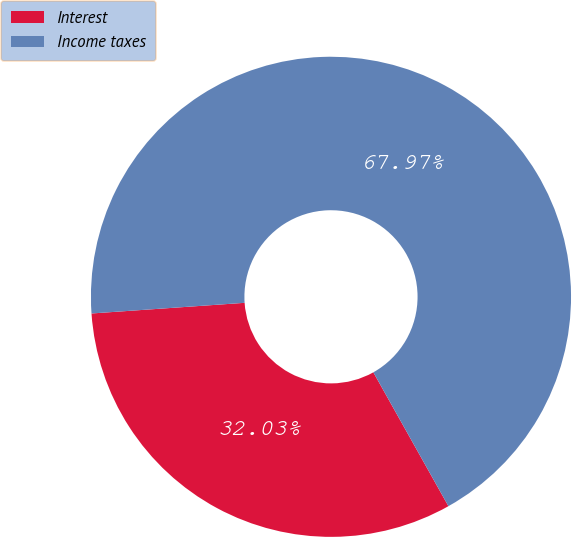<chart> <loc_0><loc_0><loc_500><loc_500><pie_chart><fcel>Interest<fcel>Income taxes<nl><fcel>32.03%<fcel>67.97%<nl></chart> 